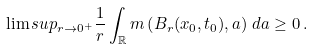<formula> <loc_0><loc_0><loc_500><loc_500>\lim s u p _ { r \rightarrow 0 ^ { + } } \frac { 1 } { r } \int _ { \mathbb { R } } m \left ( B _ { r } ( x _ { 0 } , t _ { 0 } ) , a \right ) \, d a \geq 0 \, .</formula> 